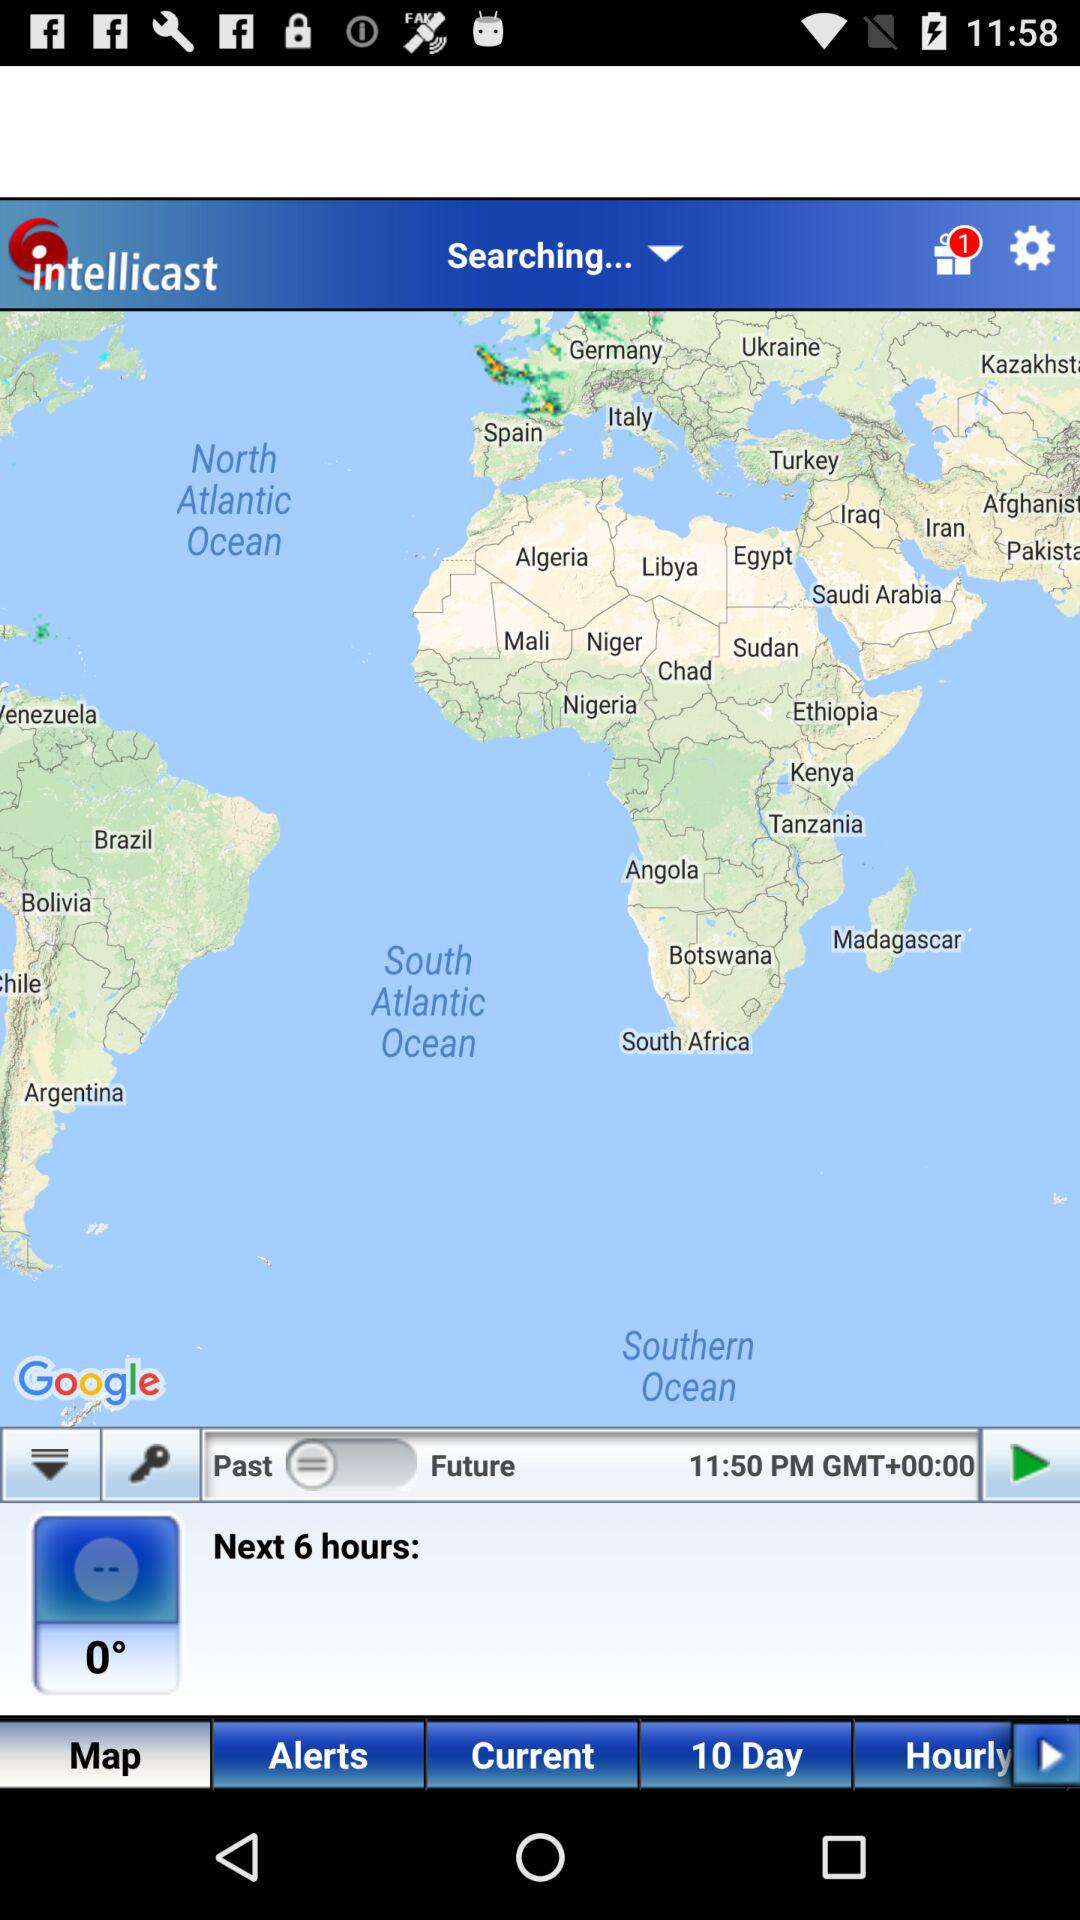What is the temperature?
Answer the question using a single word or phrase. 0° 